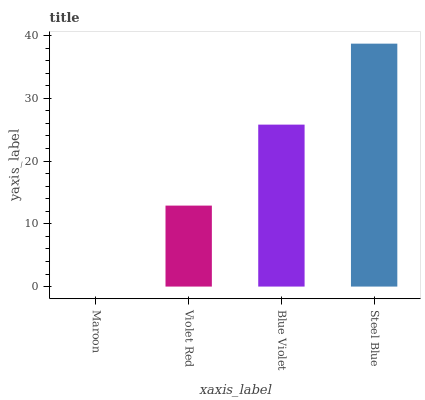Is Violet Red the minimum?
Answer yes or no. No. Is Violet Red the maximum?
Answer yes or no. No. Is Violet Red greater than Maroon?
Answer yes or no. Yes. Is Maroon less than Violet Red?
Answer yes or no. Yes. Is Maroon greater than Violet Red?
Answer yes or no. No. Is Violet Red less than Maroon?
Answer yes or no. No. Is Blue Violet the high median?
Answer yes or no. Yes. Is Violet Red the low median?
Answer yes or no. Yes. Is Maroon the high median?
Answer yes or no. No. Is Blue Violet the low median?
Answer yes or no. No. 